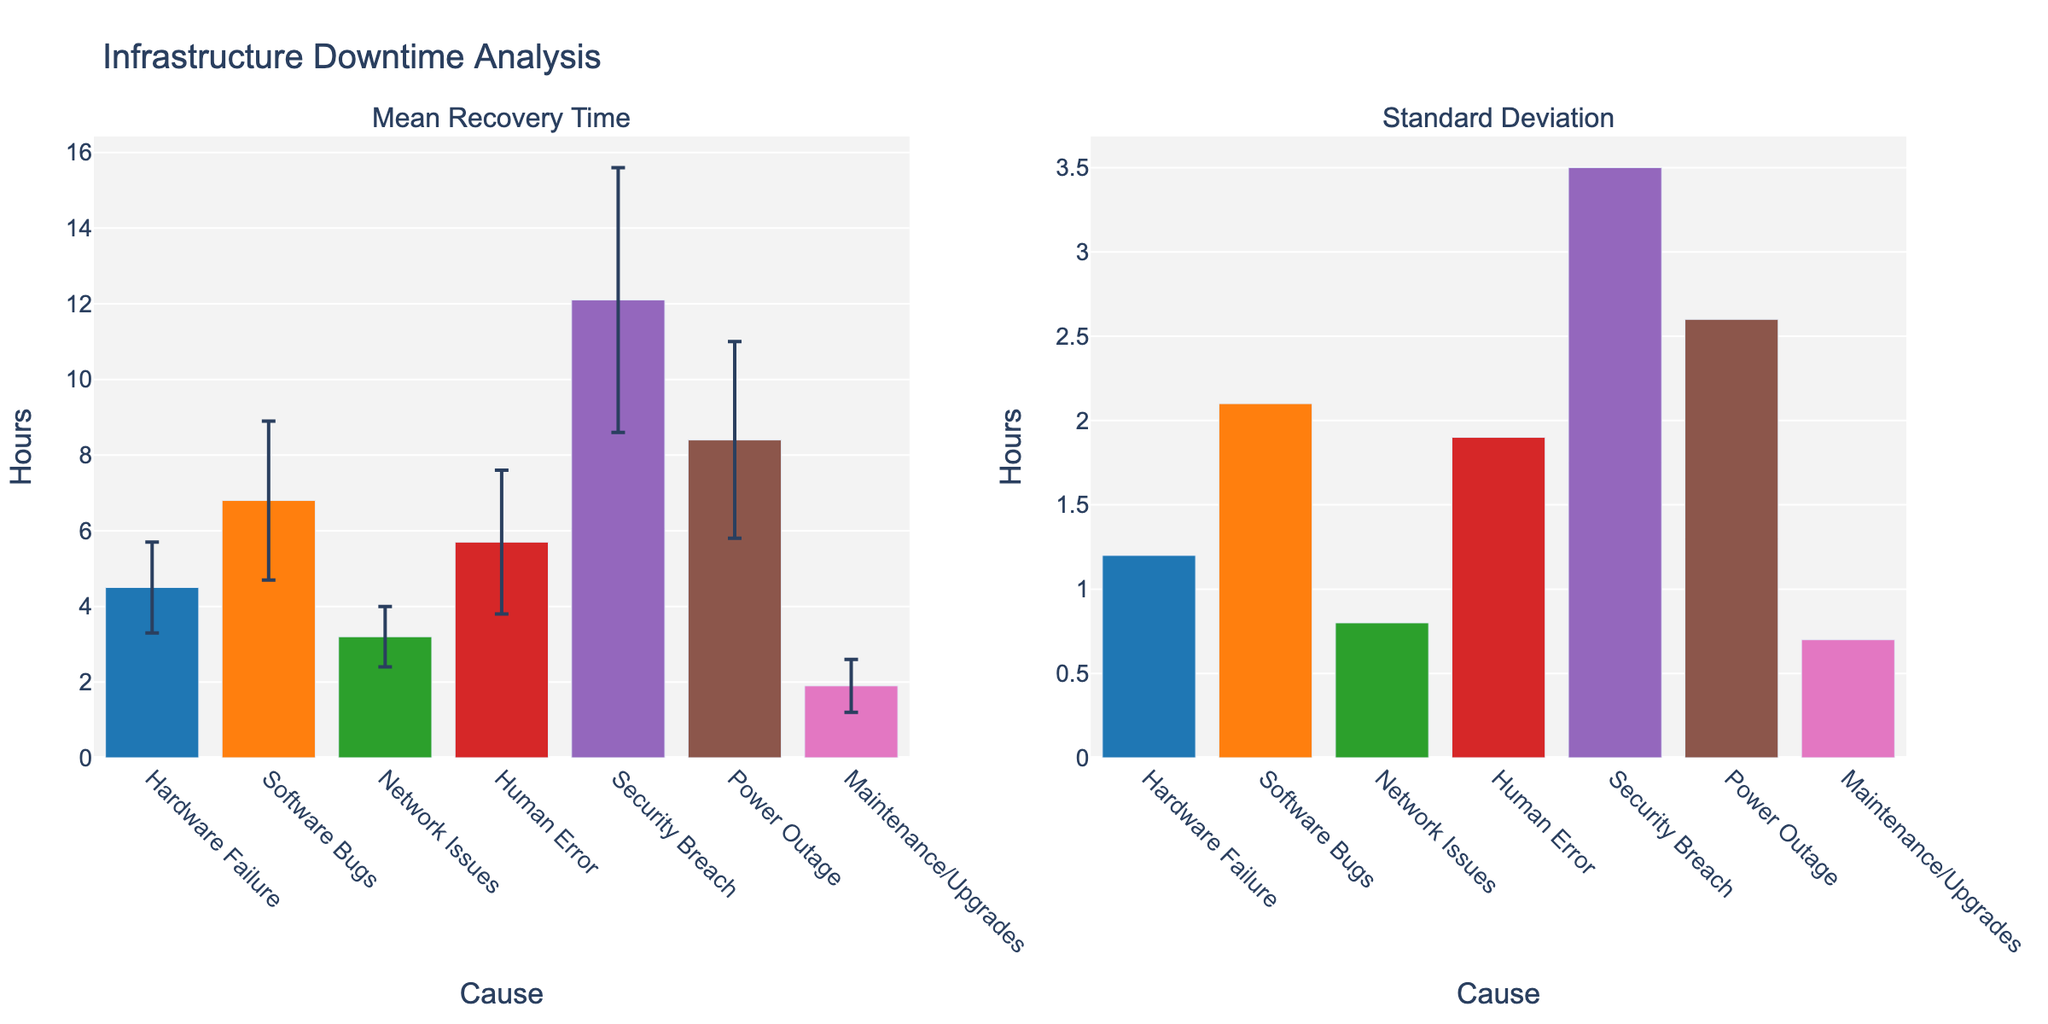Which cause has the highest mean recovery time? Looking at the "Mean Recovery Time" subplot, the tallest bar represents the cause with the highest mean recovery time. Here, "Security Breach" has the highest bar.
Answer: Security Breach What is the mean recovery time for Hardware Failure? Refer to the "Mean Recovery Time" subplot and find the bar labeled "Hardware Failure." The height of this bar indicates the mean recovery time, which is shown as 4.5 hours.
Answer: 4.5 hours Which cause has the smallest standard deviation in recovery time? Look at the "Standard Deviation" subplot, and identify the smallest bar. The cause with the smallest bar is "Maintenance/Upgrades."
Answer: Maintenance/Upgrades How much higher is the mean recovery time for a Security Breach compared to a Network Issue? From the "Mean Recovery Time" subplot, Security Breach is 12.1 hours, and Network Issue is 3.2 hours. Subtracting these gives 12.1 - 3.2 = 8.9 hours.
Answer: 8.9 hours Which cause has a greater standard deviation: Power Outage or Software Bugs? In the "Standard Deviation" subplot, compare the heights of the bars for "Power Outage" and "Software Bugs." "Power Outage" has a higher bar than "Software Bugs."
Answer: Power Outage What is the range of mean recovery times shown in the figure? To find the range, subtract the smallest mean recovery time from the largest. The smallest is for "Maintenance/Upgrades" at 1.9 hours, and the largest is for "Security Breach" at 12.1 hours. So, 12.1 - 1.9 = 10.2 hours.
Answer: 10.2 hours How does the mean recovery time of Human Error compare to that of Power Outage? From the "Mean Recovery Time" subplot, Human Error has a mean recovery time of 5.7 hours, and Power Outage has 8.4 hours. Human Error has a lower mean recovery time.
Answer: Human Error is lower What is the total sample size across all causes? Add the sample sizes for all causes: 50 + 47 + 52 + 45 + 38 + 43 + 55 = 330.
Answer: 330 Considering the error bars, which cause's mean recovery time appears to be the most uncertain? The uncertainty is represented by the error bars. The longest error bar in the "Mean Recovery Time" subplot is associated with "Security Breach."
Answer: Security Breach Is the standard deviation for Software Bugs higher or lower than the mean recovery time for Network Issues? From the "Standard Deviation" subplot, the standard deviation for Software Bugs is 2.1 hours, and from the "Mean Recovery Time" subplot, the mean recovery time for Network Issues is 3.2 hours. Since 2.1 is less than 3.2, the standard deviation is lower.
Answer: Lower 